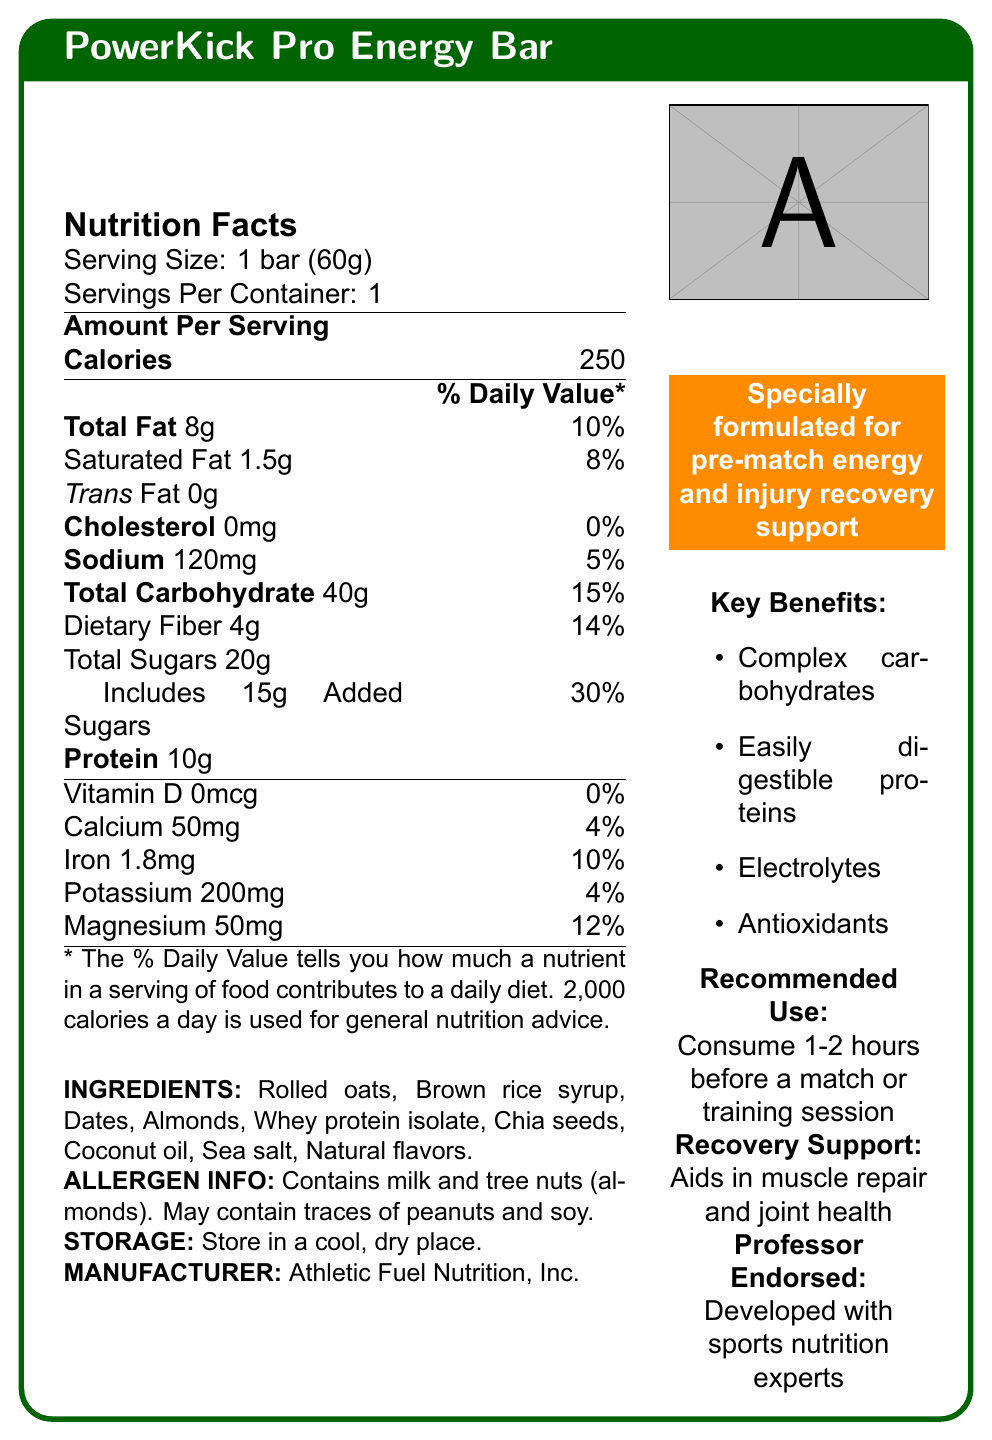what is the serving size for the PowerKick Pro Energy Bar? The document specifies that the serving size is 1 bar weighing 60 grams.
Answer: 1 bar (60g) how many calories are in one bar? The Nutrition Facts section lists the calorie content per serving as 250 calories.
Answer: 250 what percentage of the daily value of total fat does one bar provide? The document states that one bar provides 8 grams of total fat, which is 10% of the daily value.
Answer: 10% how much dietary fiber is in one bar? The Nutrition Facts section shows that one bar contains 4 grams of dietary fiber.
Answer: 4g which ingredients in the PowerKick Pro Energy Bar are allergens? The allergen info in the document highlights that the bar contains milk and tree nuts (almonds).
Answer: Milk and tree nuts (almonds) how much protein does the PowerKick Pro Energy Bar contain? The Nutrition Facts section lists 10 grams of protein per bar.
Answer: 10g how much added sugar is in the bar? The document states that it includes 15 grams of added sugars.
Answer: 15g what are the key benefits of the PowerKick Pro Energy Bar? The key benefits section lists these components which are beneficial.
Answer: Complex carbohydrates, Easily digestible proteins, Electrolytes, Antioxidants who is the manufacturer of the PowerKick Pro Energy Bar? The document mentions that the manufacturer is Athletic Fuel Nutrition, Inc.
Answer: Athletic Fuel Nutrition, Inc. what is the recommended use for the bar? The recommended use section advises consuming the bar 1-2 hours before an activity.
Answer: Consume 1-2 hours before a match or training session which nutrient contributes 30% to the daily value? 
A. Sodium
B. Dietary Fiber
C. Added Sugars
D. Calcium The daily value percentage for added sugars is 30%, according to the Nutrition Facts section.
Answer: C how much magnesium is in one bar and what is its daily value percentage? 
A. 50mg, 4%
B. 50mg, 12%
C. 50mg, 5%
D. 50mg, 10% The document specifies that one bar contains 50mg of magnesium, which is 12% of the daily value.
Answer: B does the PowerKick Pro Energy Bar contain any cholesterol? The Nutrition Facts section indicates that it contains 0mg of cholesterol, which is 0% of the daily value.
Answer: No can you determine the cost of one PowerKick Pro Energy Bar from this document? The document does not provide any information about the cost of the energy bar.
Answer: Not enough information summarize the main idea of the document. The document primarily focuses on the detailed nutritional information, key benefits, and recommended usage guidelines for the PowerKick Pro Energy Bar, aiming to highlight its suitability for athletes in need of energy and recovery support.
Answer: The document provides the Nutrition Facts for the PowerKick Pro Energy Bar, highlighting its nutritional content, key ingredients, allergen information, and benefits for pre-match energy and recovery support. It also outlines that the bar is designed for consumption 1-2 hours before a match, supports muscle repair, and is developed with input from sports nutrition experts. 